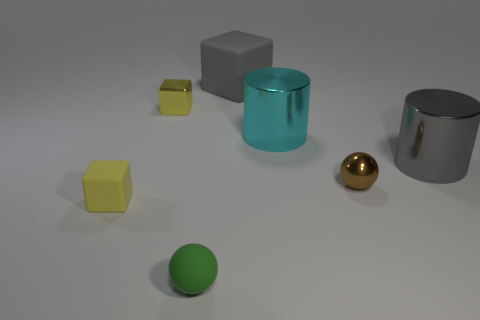Subtract all large gray matte blocks. How many blocks are left? 2 Subtract all gray blocks. How many blocks are left? 2 Add 1 tiny cubes. How many objects exist? 8 Subtract 1 spheres. How many spheres are left? 1 Subtract all cylinders. How many objects are left? 5 Add 4 small green matte things. How many small green matte things are left? 5 Add 3 gray cylinders. How many gray cylinders exist? 4 Subtract 0 cyan spheres. How many objects are left? 7 Subtract all gray spheres. Subtract all cyan cylinders. How many spheres are left? 2 Subtract all yellow spheres. How many yellow blocks are left? 2 